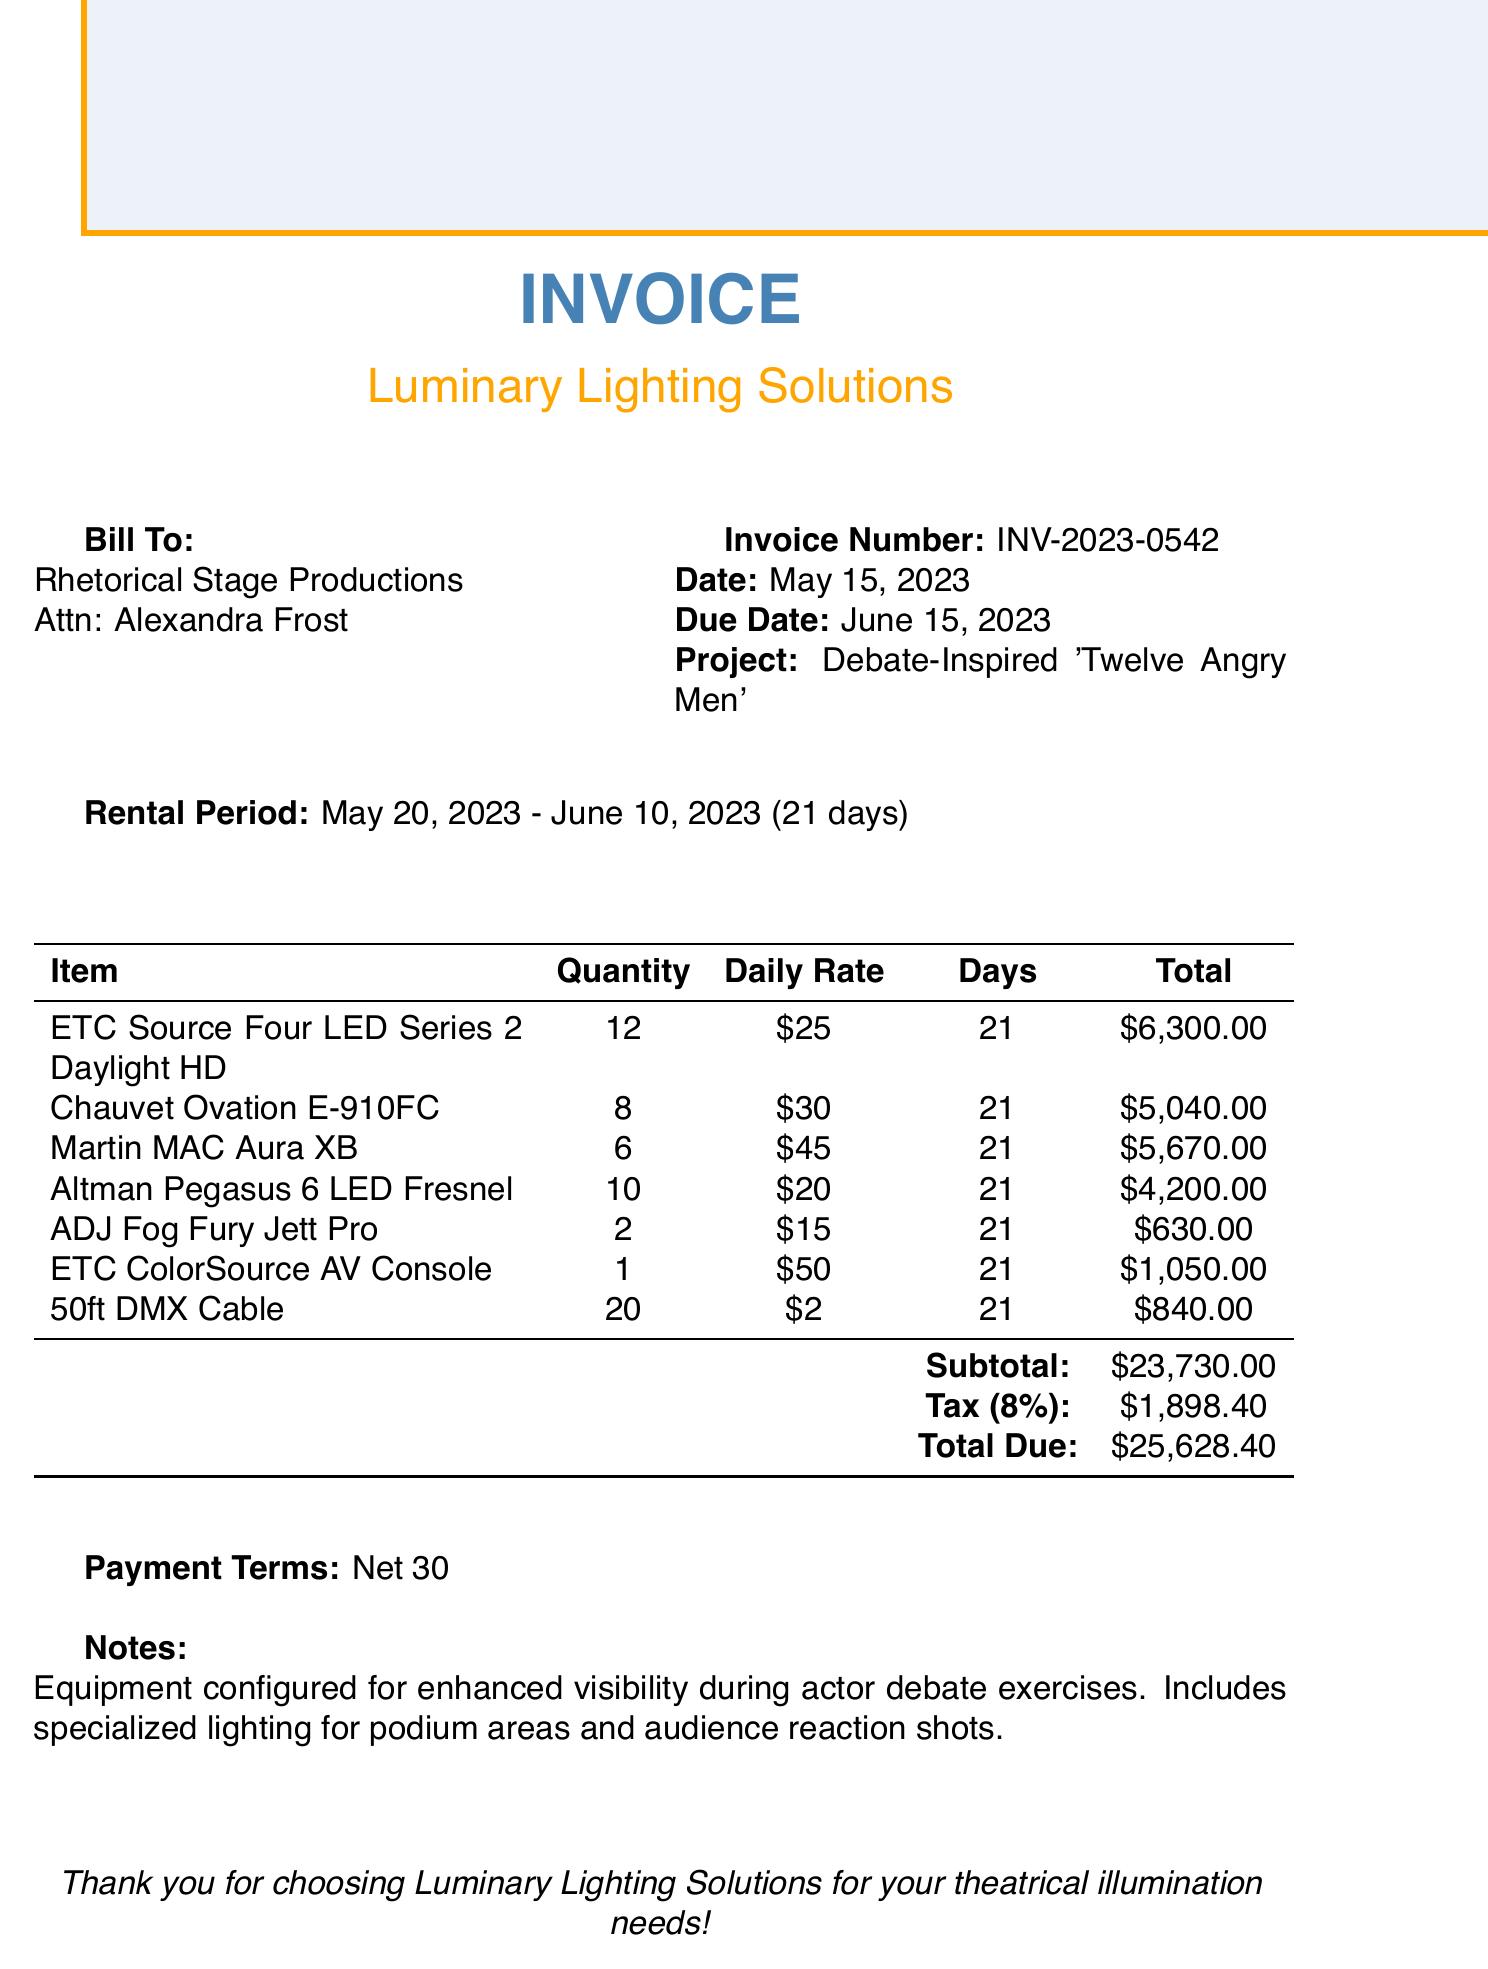What is the invoice number? The invoice number is explicitly stated in the document as INV-2023-0542.
Answer: INV-2023-0542 What is the due date for this invoice? The due date is specified as June 15, 2023.
Answer: June 15, 2023 How many ETC Source Four LED fixtures were rented? The document lists that 12 ETC Source Four LED Series 2 Daylight HD fixtures were rented.
Answer: 12 What is the tax amount? The document shows that the tax amount calculated is $1,898.40.
Answer: $1,898.40 What is the rental period for the equipment? The rental period is detailed in the document from May 20, 2023, to June 10, 2023.
Answer: May 20, 2023 - June 10, 2023 How many days was the equipment rented for? The total rental duration stated is 21 days.
Answer: 21 days What is the total amount due? The total due amount is provided in the document, which is $25,628.40.
Answer: $25,628.40 What company issued this invoice? The invoice indicates that it was issued by Luminary Lighting Solutions.
Answer: Luminary Lighting Solutions What type of project is this invoice for? The document specifies that the project is "Debate-Inspired 'Twelve Angry Men'."
Answer: Debate-Inspired 'Twelve Angry Men' 